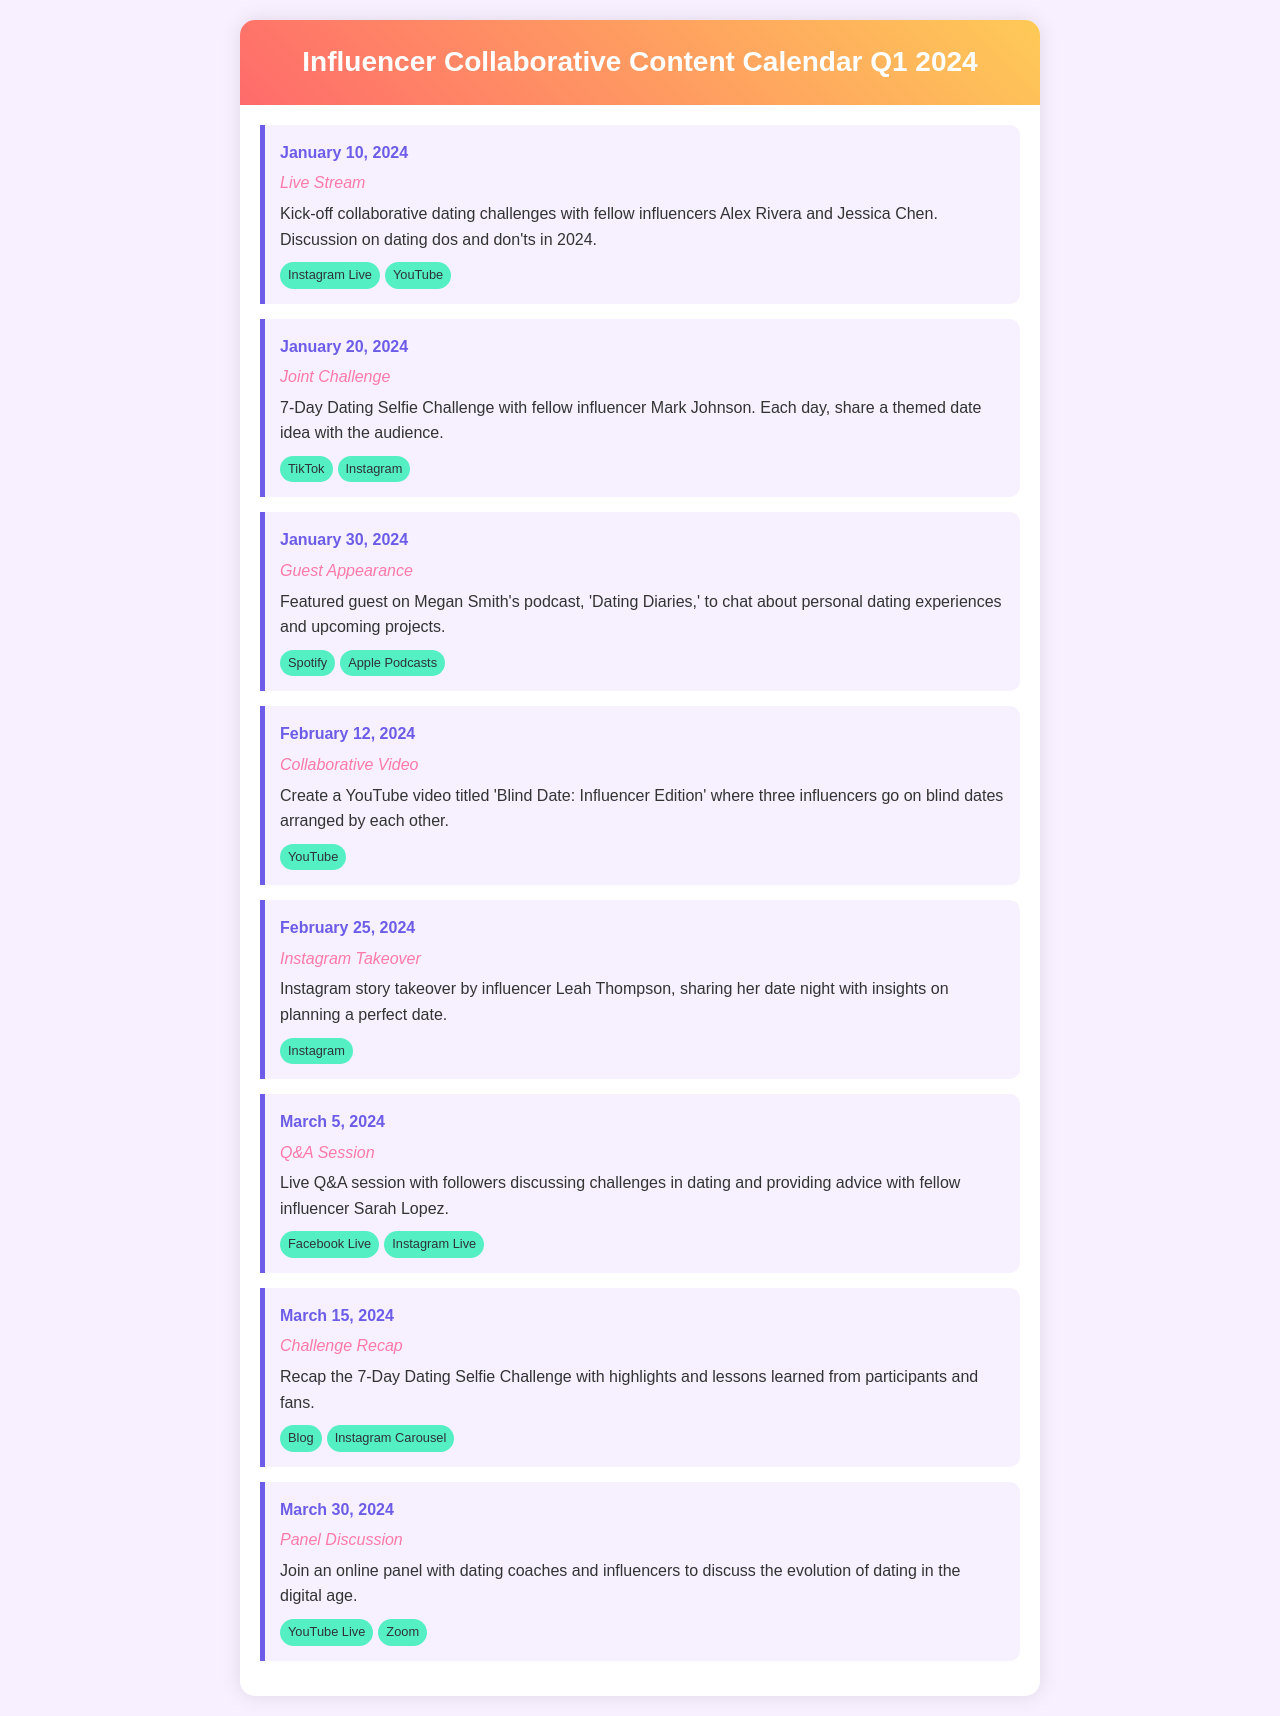What is the first event in the calendar? The first event listed is on January 10, 2024, which is a Live Stream.
Answer: Live Stream Who is joining the January 20 event? The January 20 event is a Joint Challenge featuring fellow influencer Mark Johnson.
Answer: Mark Johnson How many days does the January 20 challenge last? The challenge is described as a 7-Day Dating Selfie Challenge.
Answer: 7 days What type of event is scheduled for February 12, 2024? The event on February 12, 2024, is a Collaborative Video.
Answer: Collaborative Video Which platform will host the live Q&A session on March 5, 2024? The Q&A session will be held on Facebook Live and Instagram Live.
Answer: Facebook Live, Instagram Live What is the main topic of the March 30 event? The March 30 event discusses the evolution of dating in the digital age.
Answer: The evolution of dating in the digital age What is the title of the podcast for the guest appearance on January 30? The podcast is titled 'Dating Diaries.'
Answer: Dating Diaries On which date will the Instagram story takeover happen? The Instagram story takeover is scheduled for February 25, 2024.
Answer: February 25, 2024 What event follows the 7-Day Dating Selfie Challenge? The event that follows is a Challenge Recap on March 15, 2024.
Answer: Challenge Recap 